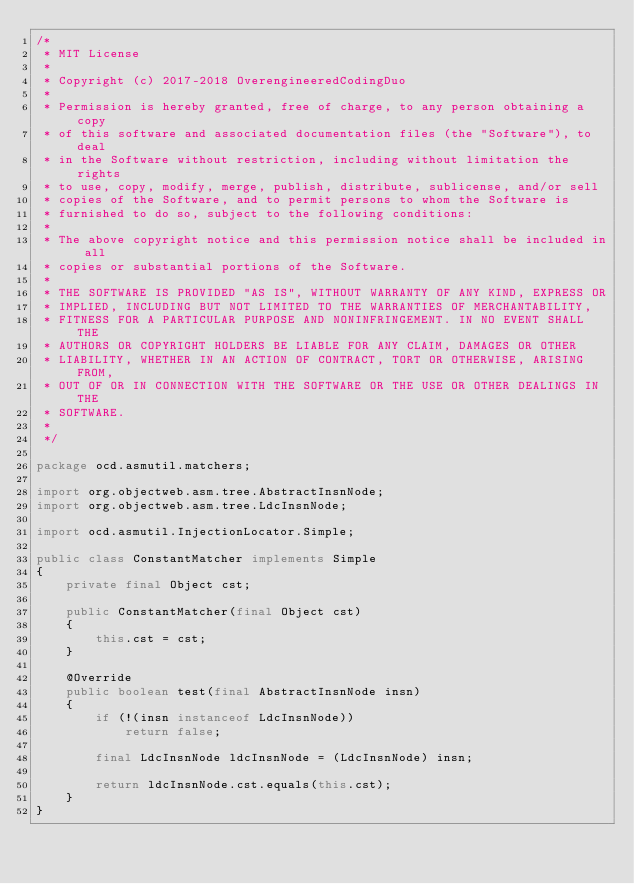Convert code to text. <code><loc_0><loc_0><loc_500><loc_500><_Java_>/*
 * MIT License
 *
 * Copyright (c) 2017-2018 OverengineeredCodingDuo
 *
 * Permission is hereby granted, free of charge, to any person obtaining a copy
 * of this software and associated documentation files (the "Software"), to deal
 * in the Software without restriction, including without limitation the rights
 * to use, copy, modify, merge, publish, distribute, sublicense, and/or sell
 * copies of the Software, and to permit persons to whom the Software is
 * furnished to do so, subject to the following conditions:
 *
 * The above copyright notice and this permission notice shall be included in all
 * copies or substantial portions of the Software.
 *
 * THE SOFTWARE IS PROVIDED "AS IS", WITHOUT WARRANTY OF ANY KIND, EXPRESS OR
 * IMPLIED, INCLUDING BUT NOT LIMITED TO THE WARRANTIES OF MERCHANTABILITY,
 * FITNESS FOR A PARTICULAR PURPOSE AND NONINFRINGEMENT. IN NO EVENT SHALL THE
 * AUTHORS OR COPYRIGHT HOLDERS BE LIABLE FOR ANY CLAIM, DAMAGES OR OTHER
 * LIABILITY, WHETHER IN AN ACTION OF CONTRACT, TORT OR OTHERWISE, ARISING FROM,
 * OUT OF OR IN CONNECTION WITH THE SOFTWARE OR THE USE OR OTHER DEALINGS IN THE
 * SOFTWARE.
 *
 */

package ocd.asmutil.matchers;

import org.objectweb.asm.tree.AbstractInsnNode;
import org.objectweb.asm.tree.LdcInsnNode;

import ocd.asmutil.InjectionLocator.Simple;

public class ConstantMatcher implements Simple
{
	private final Object cst;

	public ConstantMatcher(final Object cst)
	{
		this.cst = cst;
	}

	@Override
	public boolean test(final AbstractInsnNode insn)
	{
		if (!(insn instanceof LdcInsnNode))
			return false;

		final LdcInsnNode ldcInsnNode = (LdcInsnNode) insn;

		return ldcInsnNode.cst.equals(this.cst);
	}
}
</code> 